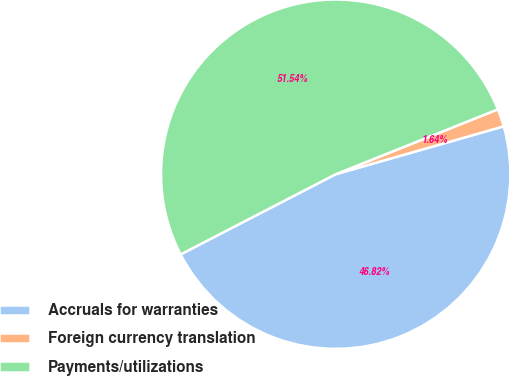Convert chart. <chart><loc_0><loc_0><loc_500><loc_500><pie_chart><fcel>Accruals for warranties<fcel>Foreign currency translation<fcel>Payments/utilizations<nl><fcel>46.82%<fcel>1.64%<fcel>51.54%<nl></chart> 